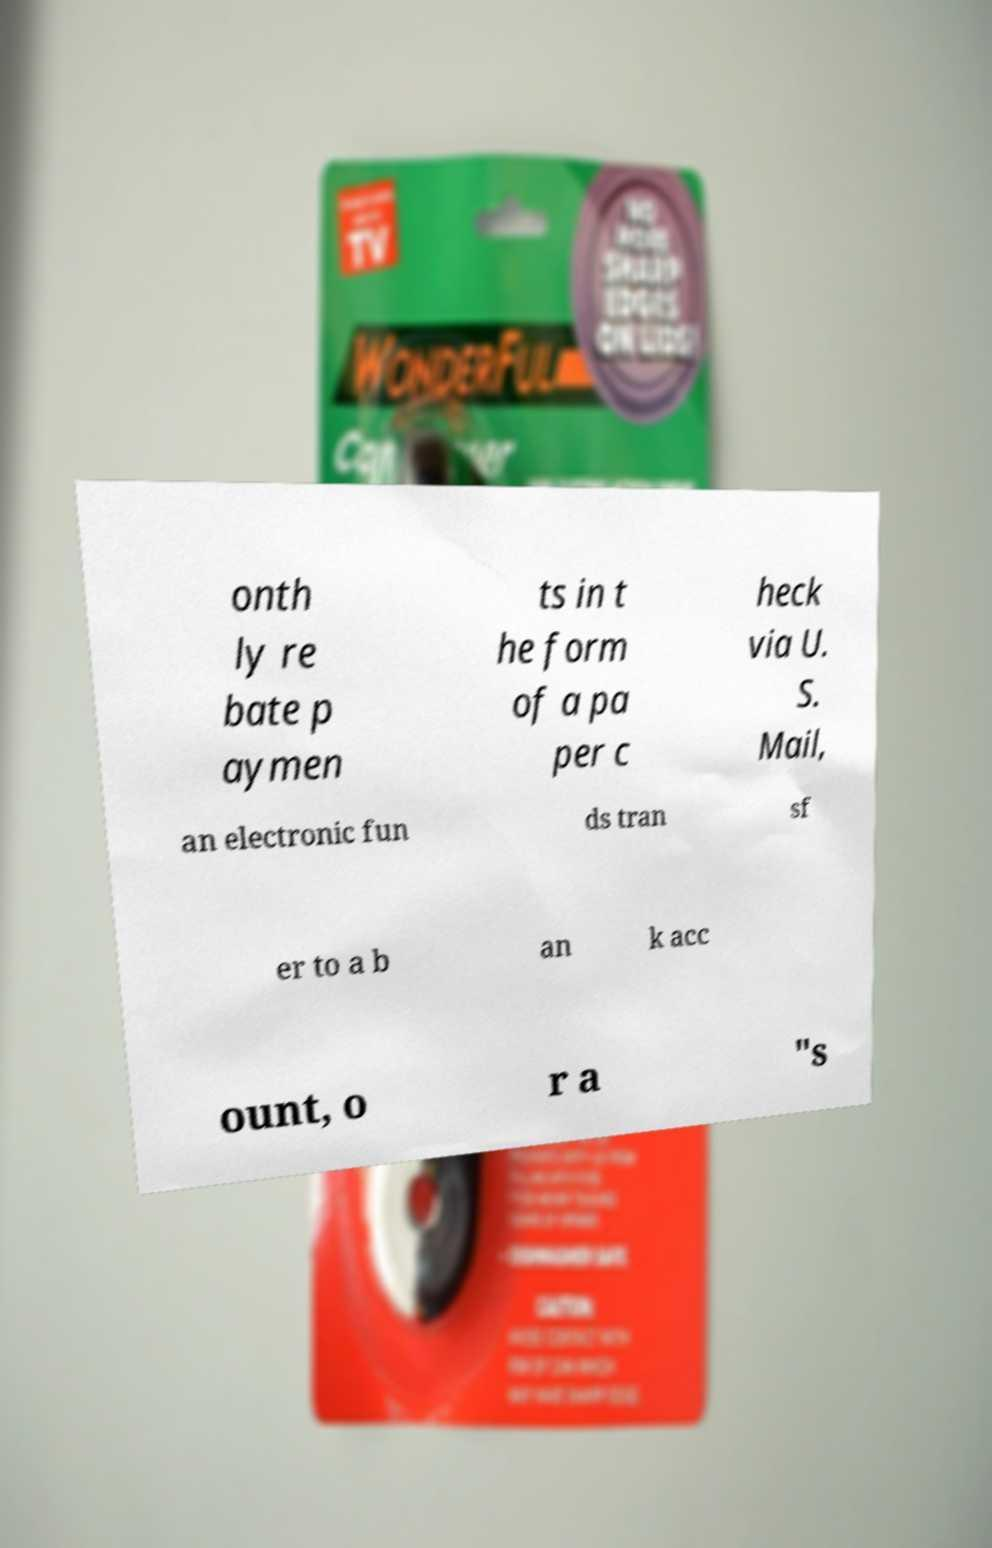Can you read and provide the text displayed in the image?This photo seems to have some interesting text. Can you extract and type it out for me? onth ly re bate p aymen ts in t he form of a pa per c heck via U. S. Mail, an electronic fun ds tran sf er to a b an k acc ount, o r a "s 